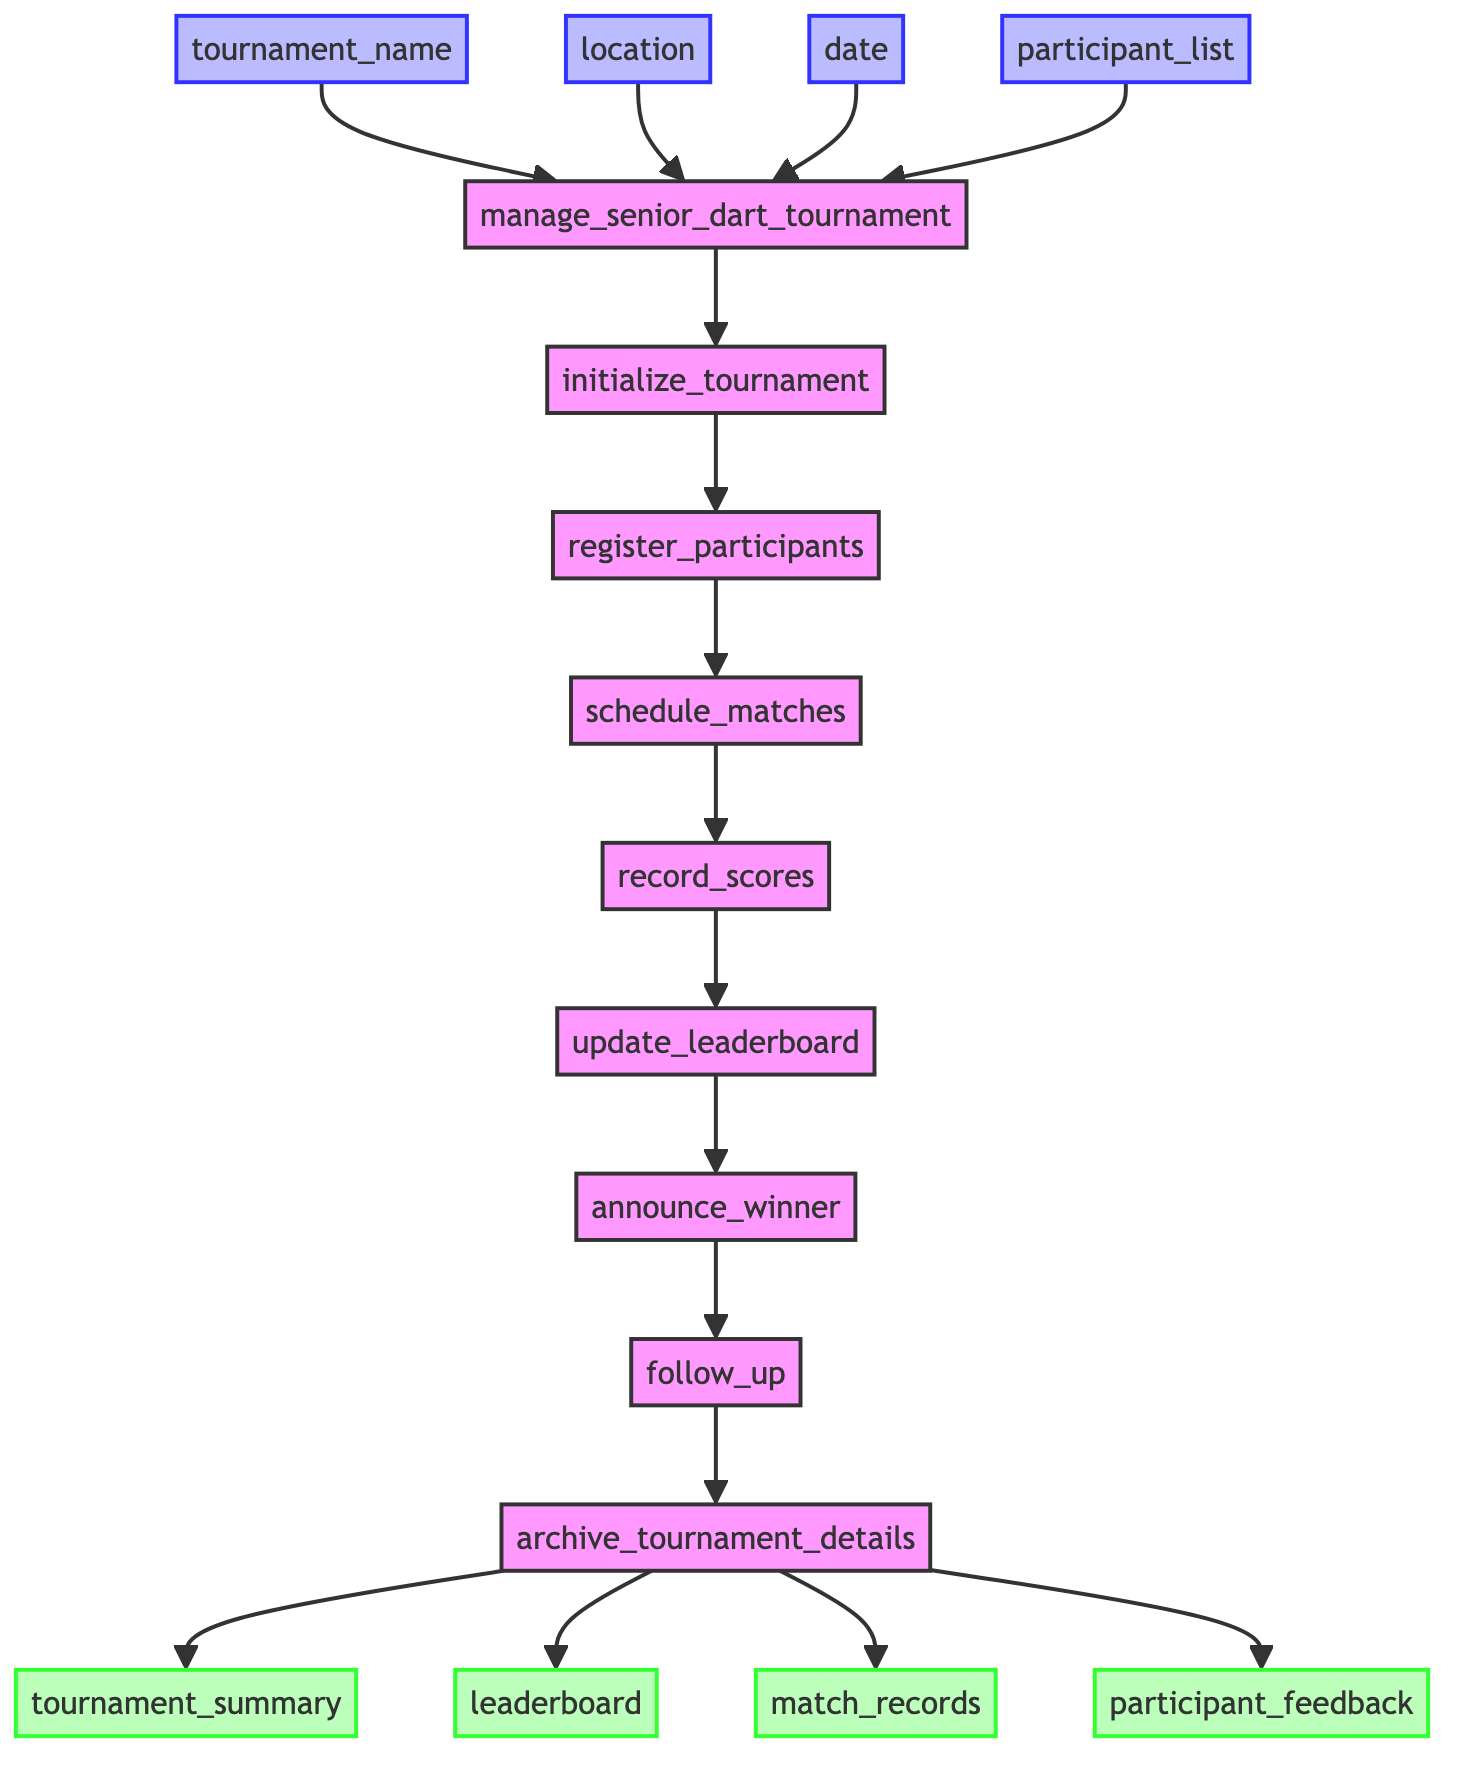What is the first step in the tournament management process? The first step is represented by the node "initialize_tournament," which sets up the tournament with its name, location, and date.
Answer: initialize_tournament How many outputs are there in this function? The function shows four distinct outputs: tournament summary, leaderboard, match records, and participant feedback, all depicted as nodes after the archiving step.
Answer: four What step comes after recording scores? The flowchart indicates that "update_leaderboard" follows the step "record_scores," making it the next action taken in the process.
Answer: update_leaderboard What are the inputs required for the function? The diagram displays four input nodes: tournament name, location, date, and participant list, which are essential for the start of the tournament management process.
Answer: tournament name, location, date, participant list What is the last step in the tournament management flow? The final step is shown as "archive_tournament_details," which is the last action taken before producing outputs, ensuring all details are stored for future reference.
Answer: archive_tournament_details Which output is related to participants' feedback? The flowchart specifies "participant_feedback" as one of the outputs, categorized as feedback collected from the participants after the tournament concludes.
Answer: participant_feedback How does the function handle participants to ensure they meet criteria? The node "register_participants" ensures that each participant is registered while confirming their eligibility based on the senior age criteria established in the function.
Answer: register_participants In which step does the tournament winner get announced? The diagram shows that "announce_winner" is the step where the winner is declared, occurring after the leaderboard has been updated based on the scores.
Answer: announce_winner What action is taken after announcing the winner? Following the "announce_winner" step, the function proceeds to "follow_up," where post-tournament feedback forms are sent to the participants.
Answer: follow_up 